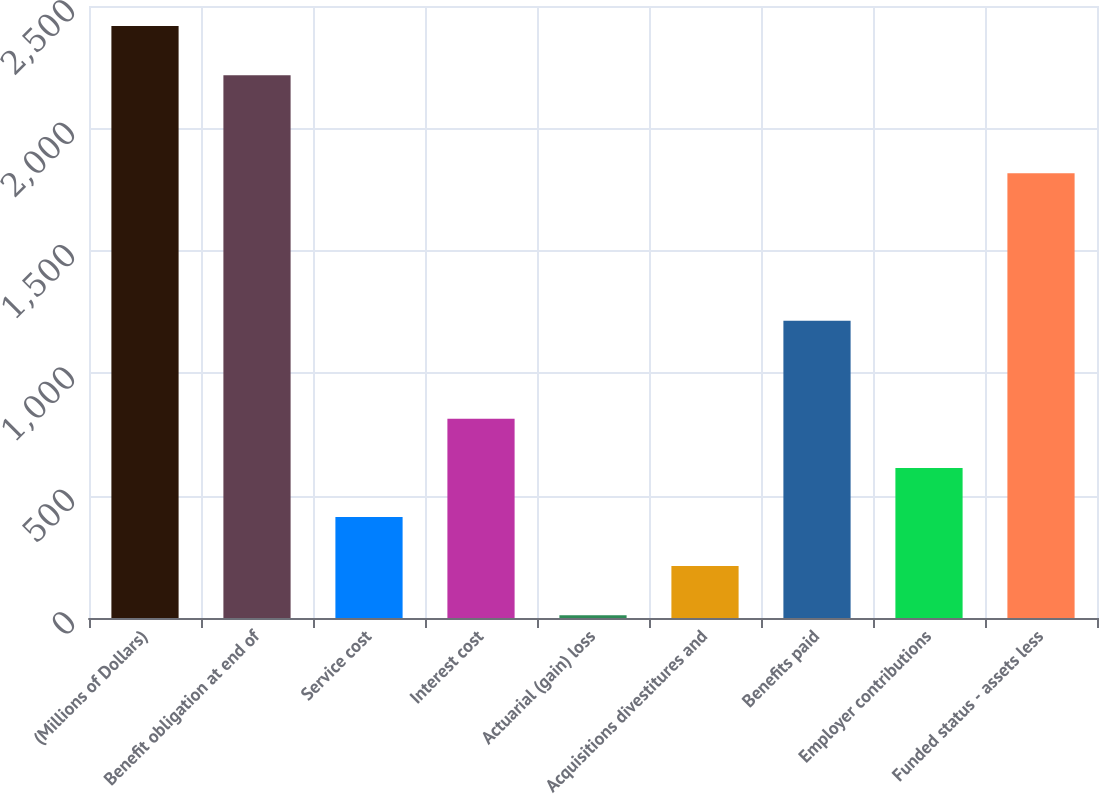Convert chart. <chart><loc_0><loc_0><loc_500><loc_500><bar_chart><fcel>(Millions of Dollars)<fcel>Benefit obligation at end of<fcel>Service cost<fcel>Interest cost<fcel>Actuarial (gain) loss<fcel>Acquisitions divestitures and<fcel>Benefits paid<fcel>Employer contributions<fcel>Funded status - assets less<nl><fcel>2418.12<fcel>2217.56<fcel>412.52<fcel>813.64<fcel>11.4<fcel>211.96<fcel>1214.76<fcel>613.08<fcel>1816.44<nl></chart> 